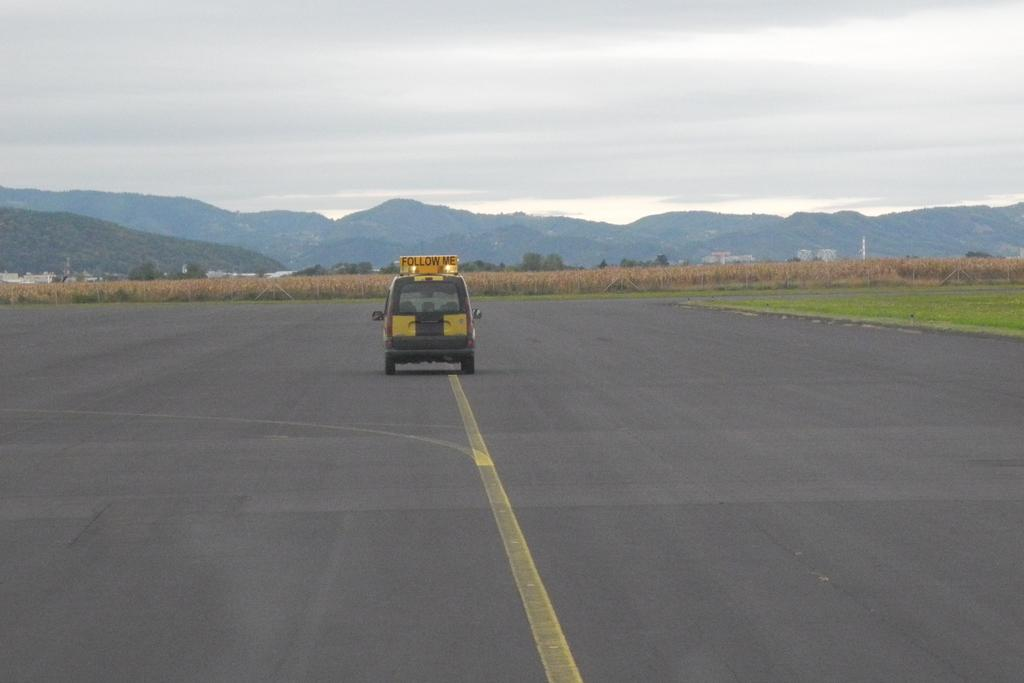What is on the road in the image? There is a vehicle on the road in the image. What is the yellow board with text used for in the image? The yellow board with text is likely a traffic sign or warning sign. What type of vegetation can be seen in the background of the image? Plants, trees, and mountains are visible in the background of the image. What is the condition of the sky in the image? The sky is cloudy in the image. Can you see a kitten climbing up the hill in the image? There is no hill or kitten present in the image. 